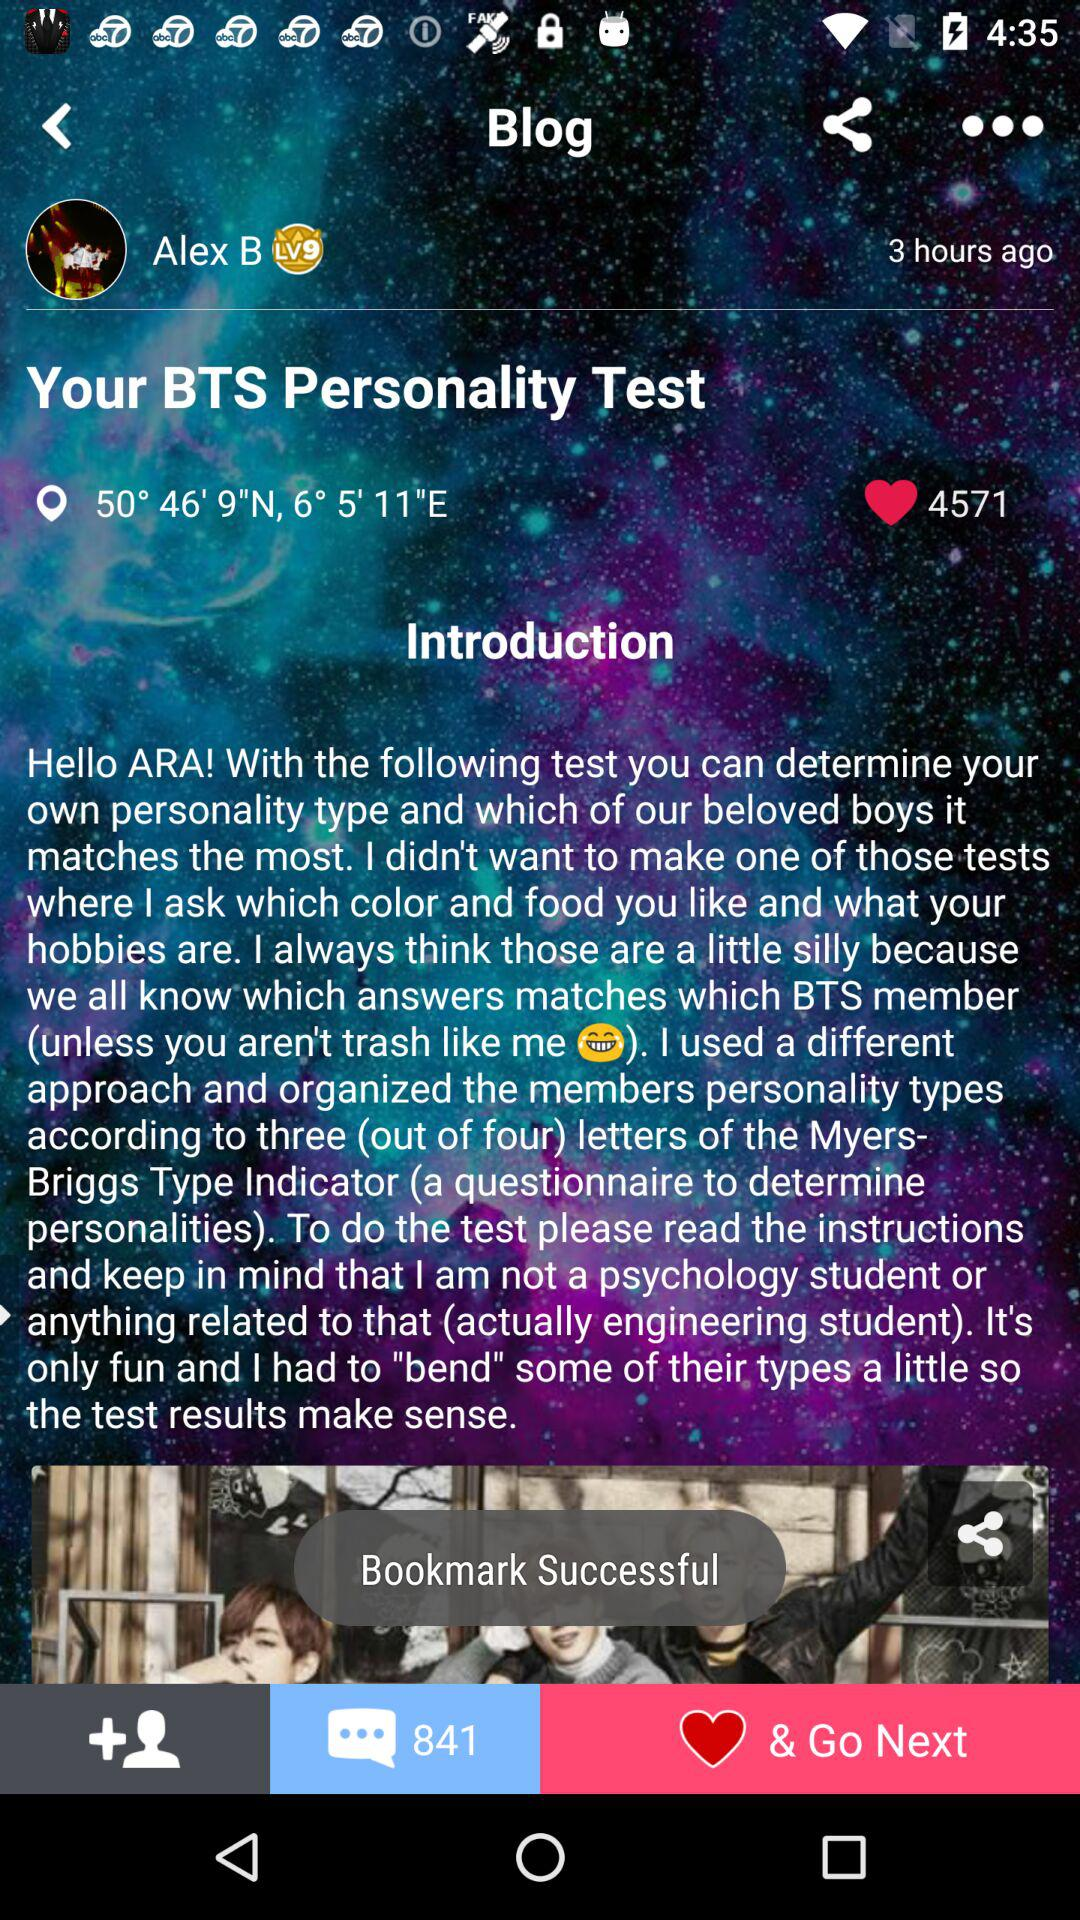How many hours ago was the post published?
Answer the question using a single word or phrase. 3 